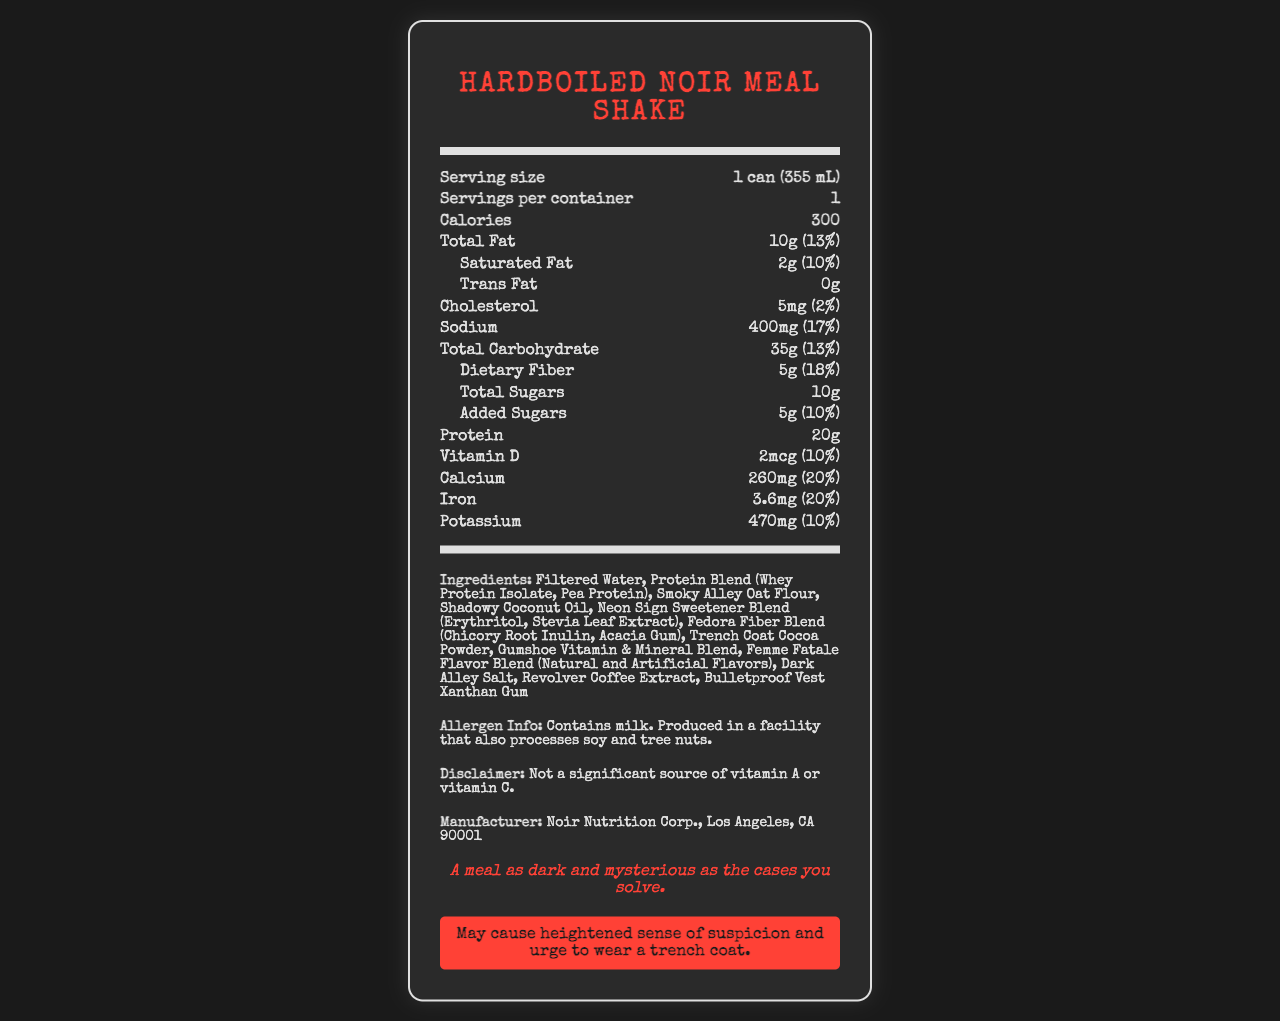how many grams of total fat are in one serving of the Hardboiled Noir Meal Shake? The document states the total fat content is 10g per serving.
Answer: 10g what is the serving size of the Hardboiled Noir Meal Shake? The document specifies the serving size as 1 can (355 mL).
Answer: 1 can (355 mL) how many grams of protein does the Hardboiled Noir Meal Shake contain? According to the document, the shake contains 20g of protein.
Answer: 20g what percentage of the daily value of calcium does one serving of the Hardboiled Noir Meal Shake provide? The document reports the calcium content is 260mg and its daily value percentage is 20%.
Answer: 20% what are the first three ingredients listed in the Hardboiled Noir Meal Shake? The ingredients are listed in decreasing order, with the first three being Filtered Water, Protein Blend (Whey Protein Isolate, Pea Protein), and Smoky Alley Oat Flour.
Answer: Filtered Water, Protein Blend (Whey Protein Isolate, Pea Protein), Smoky Alley Oat Flour how much sodium is in one serving? The document indicates that one serving contains 400mg of sodium.
Answer: 400mg which of the following vitamins or minerals has the highest percentage of daily value in one serving? 
A. Vitamin D 
B. Calcium 
C. Iron 
D. Potassium Calcium has a daily value of 20%, which is the highest among the options listed.
Answer: B how much added sugar does one serving of the Hardboiled Noir Meal Shake contain? 
A. 0g 
B. 5g 
C. 10g 
D. 15g The document states that one serving contains 5g of added sugars.
Answer: B does the Hardboiled Noir Meal Shake contain soy? The allergen information indicates it contains milk and is produced in a facility that also processes soy and tree nuts, but does not explicitly state it contains soy.
Answer: No summarize the main features of the Hardboiled Noir Meal Shake from its nutrition facts label. The document lists detailed nutritional information, ingredients, and manufacturer details about the Hardboiled Noir Meal Shake, emphasizing a noir detective theme.
Answer: The Hardboiled Noir Meal Shake is a meal replacement with 300 calories per can. It contains 10g of total fat, 20g of protein, and 35g of carbohydrates including 5g dietary fiber and 10g total sugars (5g added). It is a good source of calcium, iron, and potassium, with significant amounts of vitamin D as well. The ingredients list includes a mix of unique items such as Smoky Alley Oat Flour and Revolver Coffee Extract. The product is manufactured by Noir Nutrition Corp. and has a noir-themed tagline and warning. will drinking the Hardboiled Noir Meal Shake likely make you wear a trench coat? The warning states it "may cause heightened sense of suspicion and urge to wear a trench coat," but this is likely a playful addition rather than a factual statement.
Answer: No what is the street address of the manufacturer of the Hardboiled Noir Meal Shake? The document provides the manufacturer's name and city (Noir Nutrition Corp., Los Angeles, CA 90001), but does not include a specific street address.
Answer: Not enough information 